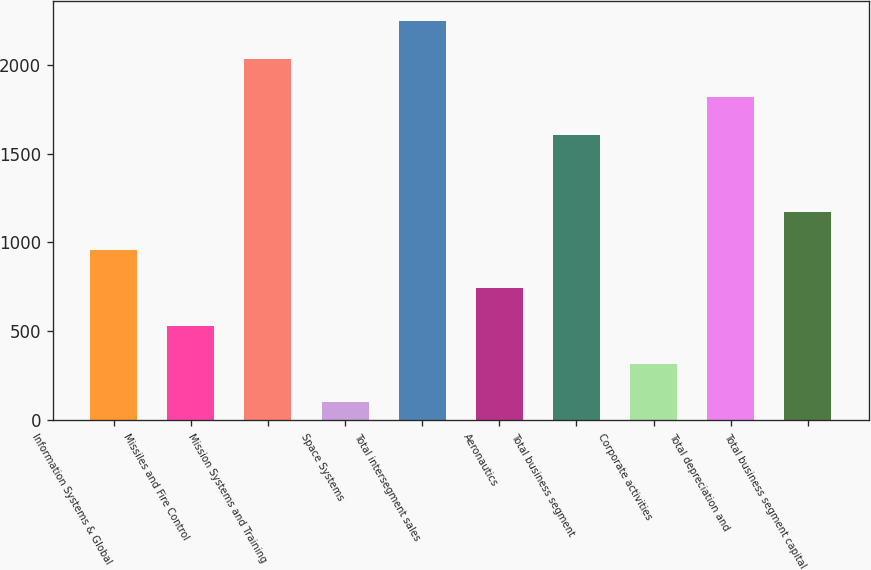Convert chart to OTSL. <chart><loc_0><loc_0><loc_500><loc_500><bar_chart><fcel>Information Systems & Global<fcel>Missiles and Fire Control<fcel>Mission Systems and Training<fcel>Space Systems<fcel>Total intersegment sales<fcel>Aeronautics<fcel>Total business segment<fcel>Corporate activities<fcel>Total depreciation and<fcel>Total business segment capital<nl><fcel>959.4<fcel>530.2<fcel>2032.4<fcel>101<fcel>2247<fcel>744.8<fcel>1603.2<fcel>315.6<fcel>1817.8<fcel>1174<nl></chart> 